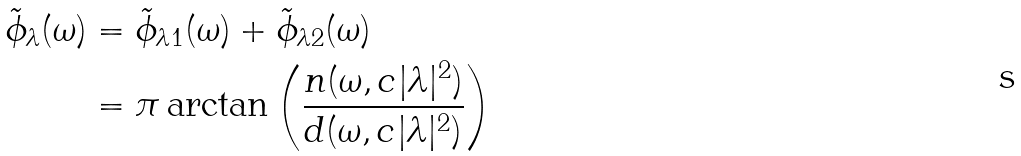<formula> <loc_0><loc_0><loc_500><loc_500>\tilde { \phi } _ { \lambda } ( \omega ) & = \tilde { \phi } _ { \lambda 1 } ( \omega ) + \tilde { \phi } _ { \lambda 2 } ( \omega ) \\ & = \pi \arctan \left ( \frac { n ( \omega , c | \lambda | ^ { 2 } ) } { d ( \omega , c | \lambda | ^ { 2 } ) } \right )</formula> 